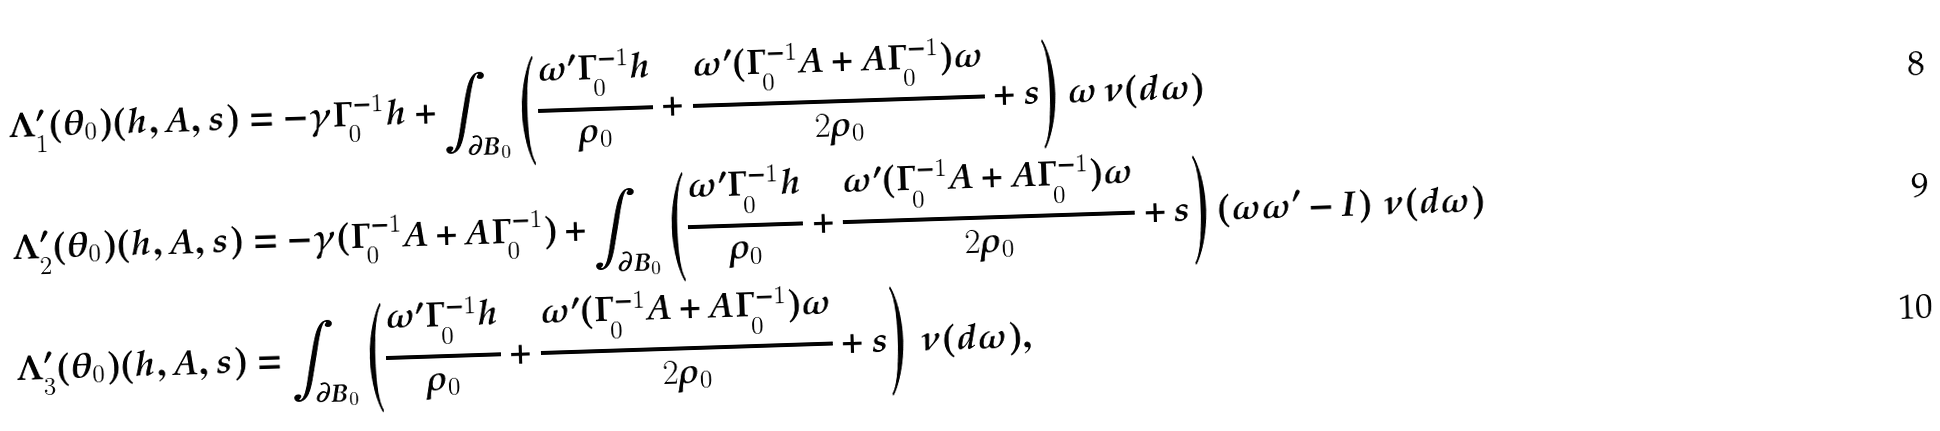<formula> <loc_0><loc_0><loc_500><loc_500>\Lambda _ { 1 } ^ { \prime } ( \theta _ { 0 } ) ( h , A , s ) & = - \gamma \Gamma _ { 0 } ^ { - 1 } h + \int _ { \partial B _ { 0 } } \left ( \frac { \omega ^ { \prime } \Gamma _ { 0 } ^ { - 1 } h } { \rho _ { 0 } } + \frac { \omega ^ { \prime } ( \Gamma _ { 0 } ^ { - 1 } A + A \Gamma _ { 0 } ^ { - 1 } ) \omega } { 2 \rho _ { 0 } } + s \right ) \omega \, \nu ( d \omega ) \\ \Lambda _ { 2 } ^ { \prime } ( \theta _ { 0 } ) ( h , A , s ) & = - \gamma ( \Gamma _ { 0 } ^ { - 1 } A + A \Gamma _ { 0 } ^ { - 1 } ) + \int _ { \partial B _ { 0 } } \left ( \frac { \omega ^ { \prime } \Gamma _ { 0 } ^ { - 1 } h } { \rho _ { 0 } } + \frac { \omega ^ { \prime } ( \Gamma _ { 0 } ^ { - 1 } A + A \Gamma _ { 0 } ^ { - 1 } ) \omega } { 2 \rho _ { 0 } } + s \right ) \left ( \omega \omega ^ { \prime } - I \right ) \, \nu ( d \omega ) \\ \Lambda _ { 3 } ^ { \prime } ( \theta _ { 0 } ) ( h , A , s ) & = \int _ { \partial B _ { 0 } } \left ( \frac { \omega ^ { \prime } \Gamma _ { 0 } ^ { - 1 } h } { \rho _ { 0 } } + \frac { \omega ^ { \prime } ( \Gamma _ { 0 } ^ { - 1 } A + A \Gamma _ { 0 } ^ { - 1 } ) \omega } { 2 \rho _ { 0 } } + s \right ) \, \nu ( d \omega ) ,</formula> 